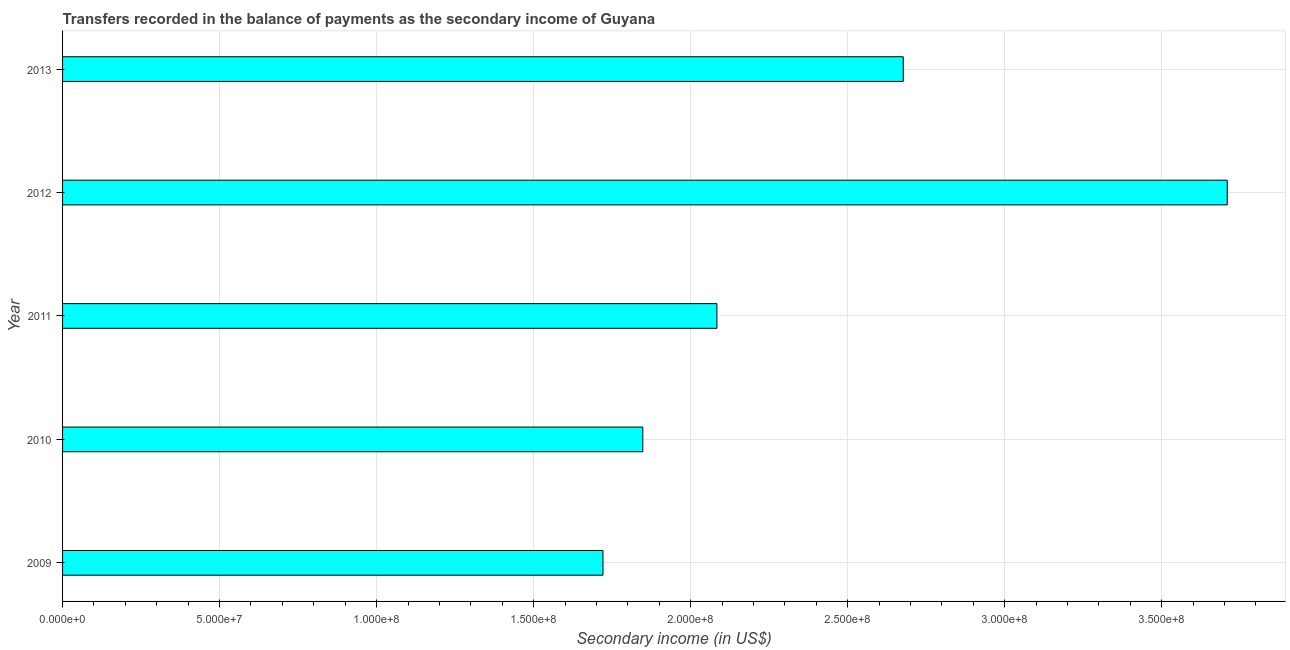Does the graph contain any zero values?
Offer a terse response. No. Does the graph contain grids?
Give a very brief answer. Yes. What is the title of the graph?
Offer a terse response. Transfers recorded in the balance of payments as the secondary income of Guyana. What is the label or title of the X-axis?
Give a very brief answer. Secondary income (in US$). What is the label or title of the Y-axis?
Make the answer very short. Year. What is the amount of secondary income in 2011?
Your answer should be very brief. 2.08e+08. Across all years, what is the maximum amount of secondary income?
Provide a short and direct response. 3.71e+08. Across all years, what is the minimum amount of secondary income?
Give a very brief answer. 1.72e+08. In which year was the amount of secondary income maximum?
Your answer should be compact. 2012. In which year was the amount of secondary income minimum?
Offer a terse response. 2009. What is the sum of the amount of secondary income?
Make the answer very short. 1.20e+09. What is the difference between the amount of secondary income in 2010 and 2012?
Provide a short and direct response. -1.86e+08. What is the average amount of secondary income per year?
Offer a very short reply. 2.41e+08. What is the median amount of secondary income?
Make the answer very short. 2.08e+08. What is the ratio of the amount of secondary income in 2011 to that in 2013?
Make the answer very short. 0.78. What is the difference between the highest and the second highest amount of secondary income?
Keep it short and to the point. 1.03e+08. Is the sum of the amount of secondary income in 2010 and 2011 greater than the maximum amount of secondary income across all years?
Provide a succinct answer. Yes. What is the difference between the highest and the lowest amount of secondary income?
Give a very brief answer. 1.99e+08. In how many years, is the amount of secondary income greater than the average amount of secondary income taken over all years?
Your response must be concise. 2. How many bars are there?
Offer a very short reply. 5. Are all the bars in the graph horizontal?
Your answer should be compact. Yes. How many years are there in the graph?
Your answer should be compact. 5. What is the difference between two consecutive major ticks on the X-axis?
Ensure brevity in your answer.  5.00e+07. What is the Secondary income (in US$) of 2009?
Ensure brevity in your answer.  1.72e+08. What is the Secondary income (in US$) in 2010?
Ensure brevity in your answer.  1.85e+08. What is the Secondary income (in US$) of 2011?
Make the answer very short. 2.08e+08. What is the Secondary income (in US$) in 2012?
Offer a terse response. 3.71e+08. What is the Secondary income (in US$) of 2013?
Provide a succinct answer. 2.68e+08. What is the difference between the Secondary income (in US$) in 2009 and 2010?
Keep it short and to the point. -1.27e+07. What is the difference between the Secondary income (in US$) in 2009 and 2011?
Offer a terse response. -3.63e+07. What is the difference between the Secondary income (in US$) in 2009 and 2012?
Your answer should be compact. -1.99e+08. What is the difference between the Secondary income (in US$) in 2009 and 2013?
Your response must be concise. -9.56e+07. What is the difference between the Secondary income (in US$) in 2010 and 2011?
Ensure brevity in your answer.  -2.36e+07. What is the difference between the Secondary income (in US$) in 2010 and 2012?
Keep it short and to the point. -1.86e+08. What is the difference between the Secondary income (in US$) in 2010 and 2013?
Provide a succinct answer. -8.29e+07. What is the difference between the Secondary income (in US$) in 2011 and 2012?
Keep it short and to the point. -1.63e+08. What is the difference between the Secondary income (in US$) in 2011 and 2013?
Your response must be concise. -5.93e+07. What is the difference between the Secondary income (in US$) in 2012 and 2013?
Keep it short and to the point. 1.03e+08. What is the ratio of the Secondary income (in US$) in 2009 to that in 2010?
Provide a short and direct response. 0.93. What is the ratio of the Secondary income (in US$) in 2009 to that in 2011?
Give a very brief answer. 0.83. What is the ratio of the Secondary income (in US$) in 2009 to that in 2012?
Your response must be concise. 0.46. What is the ratio of the Secondary income (in US$) in 2009 to that in 2013?
Provide a succinct answer. 0.64. What is the ratio of the Secondary income (in US$) in 2010 to that in 2011?
Your answer should be very brief. 0.89. What is the ratio of the Secondary income (in US$) in 2010 to that in 2012?
Your answer should be very brief. 0.5. What is the ratio of the Secondary income (in US$) in 2010 to that in 2013?
Provide a succinct answer. 0.69. What is the ratio of the Secondary income (in US$) in 2011 to that in 2012?
Provide a short and direct response. 0.56. What is the ratio of the Secondary income (in US$) in 2011 to that in 2013?
Your answer should be compact. 0.78. What is the ratio of the Secondary income (in US$) in 2012 to that in 2013?
Provide a succinct answer. 1.39. 